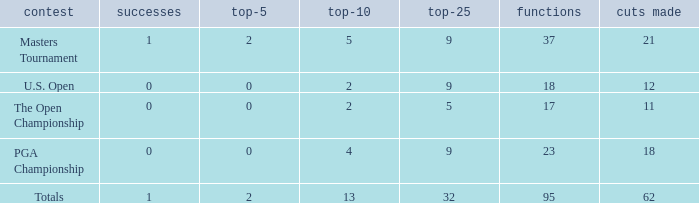What is the lowest top 5 winners with less than 0? None. 